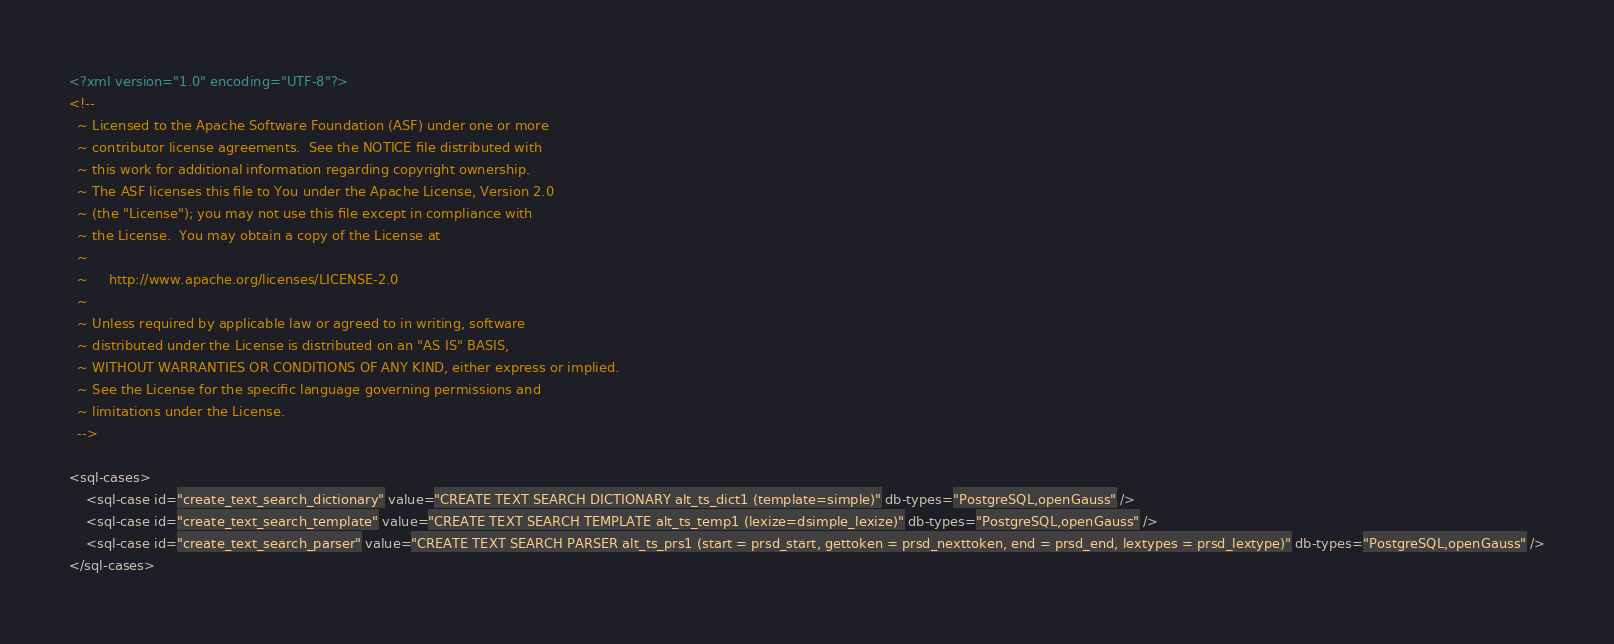<code> <loc_0><loc_0><loc_500><loc_500><_XML_><?xml version="1.0" encoding="UTF-8"?>
<!--
  ~ Licensed to the Apache Software Foundation (ASF) under one or more
  ~ contributor license agreements.  See the NOTICE file distributed with
  ~ this work for additional information regarding copyright ownership.
  ~ The ASF licenses this file to You under the Apache License, Version 2.0
  ~ (the "License"); you may not use this file except in compliance with
  ~ the License.  You may obtain a copy of the License at
  ~
  ~     http://www.apache.org/licenses/LICENSE-2.0
  ~
  ~ Unless required by applicable law or agreed to in writing, software
  ~ distributed under the License is distributed on an "AS IS" BASIS,
  ~ WITHOUT WARRANTIES OR CONDITIONS OF ANY KIND, either express or implied.
  ~ See the License for the specific language governing permissions and
  ~ limitations under the License.
  -->

<sql-cases>
    <sql-case id="create_text_search_dictionary" value="CREATE TEXT SEARCH DICTIONARY alt_ts_dict1 (template=simple)" db-types="PostgreSQL,openGauss" />
    <sql-case id="create_text_search_template" value="CREATE TEXT SEARCH TEMPLATE alt_ts_temp1 (lexize=dsimple_lexize)" db-types="PostgreSQL,openGauss" />
    <sql-case id="create_text_search_parser" value="CREATE TEXT SEARCH PARSER alt_ts_prs1 (start = prsd_start, gettoken = prsd_nexttoken, end = prsd_end, lextypes = prsd_lextype)" db-types="PostgreSQL,openGauss" />
</sql-cases>
</code> 